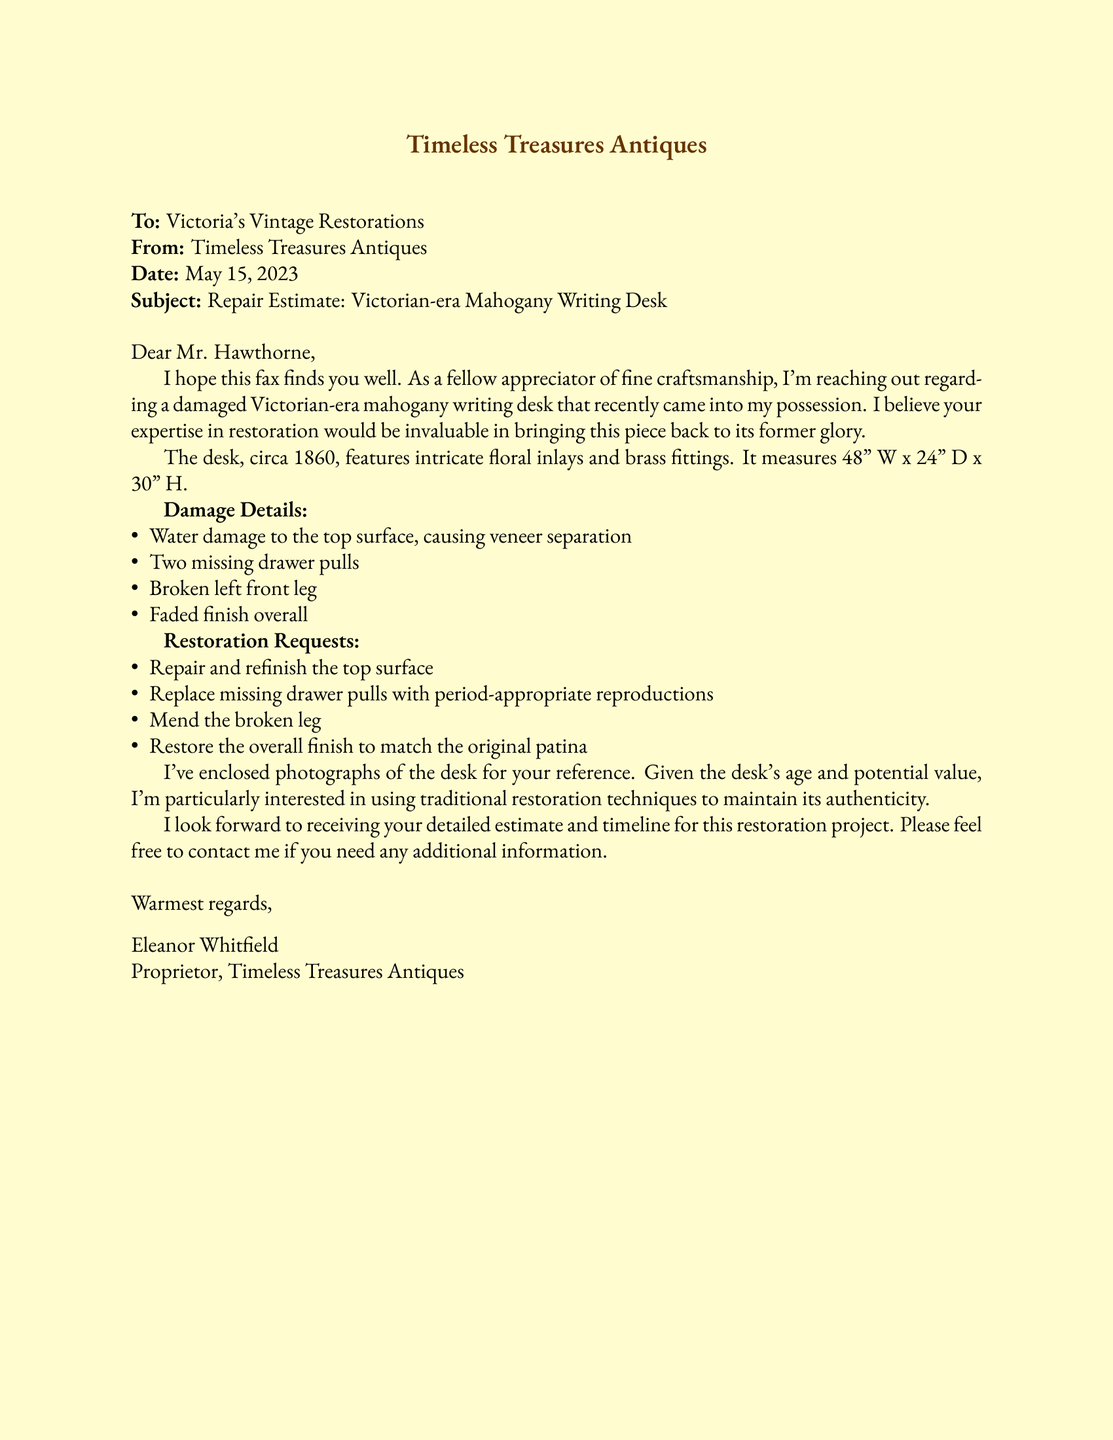who is the recipient of the fax? The recipient's name is mentioned as "Mr. Hawthorne," who represents Victoria's Vintage Restorations.
Answer: Mr. Hawthorne what is the date of the fax? The date provided in the fax is indicated clearly in the document.
Answer: May 15, 2023 what type of desk is being restored? The document specifies that the desk is a Victorian-era mahogany writing desk.
Answer: Victorian-era mahogany writing desk how many missing drawer pulls are there? The document states the number of missing drawer pulls in the damage details section.
Answer: Two what is the measurement of the desk in width? The width of the desk is specified in the document.
Answer: 48" W what restoration technique is particularly important to the proprietor? The proprietor emphasizes the importance of a specific approach to restoration in relation to the desk's authenticity.
Answer: Traditional restoration techniques what kind of inlays does the desk feature? The detail about the type of inlays is mentioned in the description of the desk.
Answer: Intricate floral inlays what is the overall condition of the desk's finish? The condition of the finish is outlined in the damage details of the document.
Answer: Faded what is the purpose of this fax? The fax communicates a specific request related to a piece of furniture.
Answer: Repair Estimate 